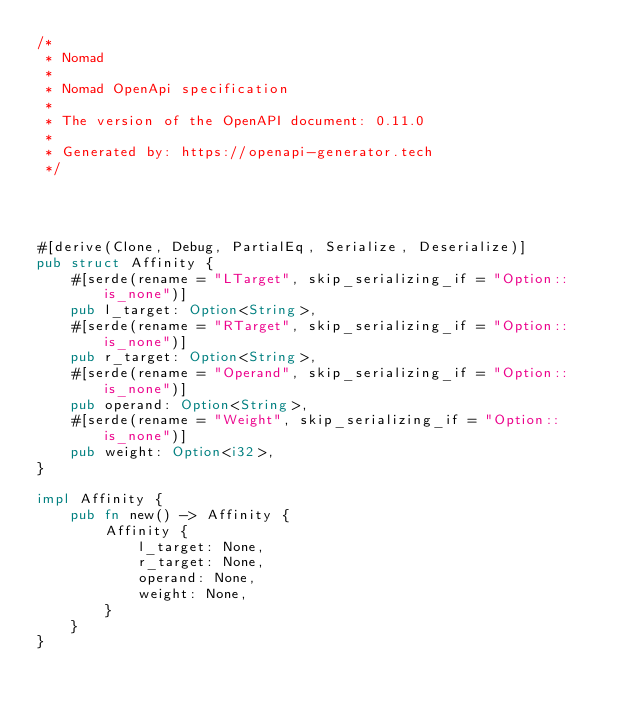Convert code to text. <code><loc_0><loc_0><loc_500><loc_500><_Rust_>/*
 * Nomad
 *
 * Nomad OpenApi specification
 *
 * The version of the OpenAPI document: 0.11.0
 * 
 * Generated by: https://openapi-generator.tech
 */




#[derive(Clone, Debug, PartialEq, Serialize, Deserialize)]
pub struct Affinity {
    #[serde(rename = "LTarget", skip_serializing_if = "Option::is_none")]
    pub l_target: Option<String>,
    #[serde(rename = "RTarget", skip_serializing_if = "Option::is_none")]
    pub r_target: Option<String>,
    #[serde(rename = "Operand", skip_serializing_if = "Option::is_none")]
    pub operand: Option<String>,
    #[serde(rename = "Weight", skip_serializing_if = "Option::is_none")]
    pub weight: Option<i32>,
}

impl Affinity {
    pub fn new() -> Affinity {
        Affinity {
            l_target: None,
            r_target: None,
            operand: None,
            weight: None,
        }
    }
}


</code> 